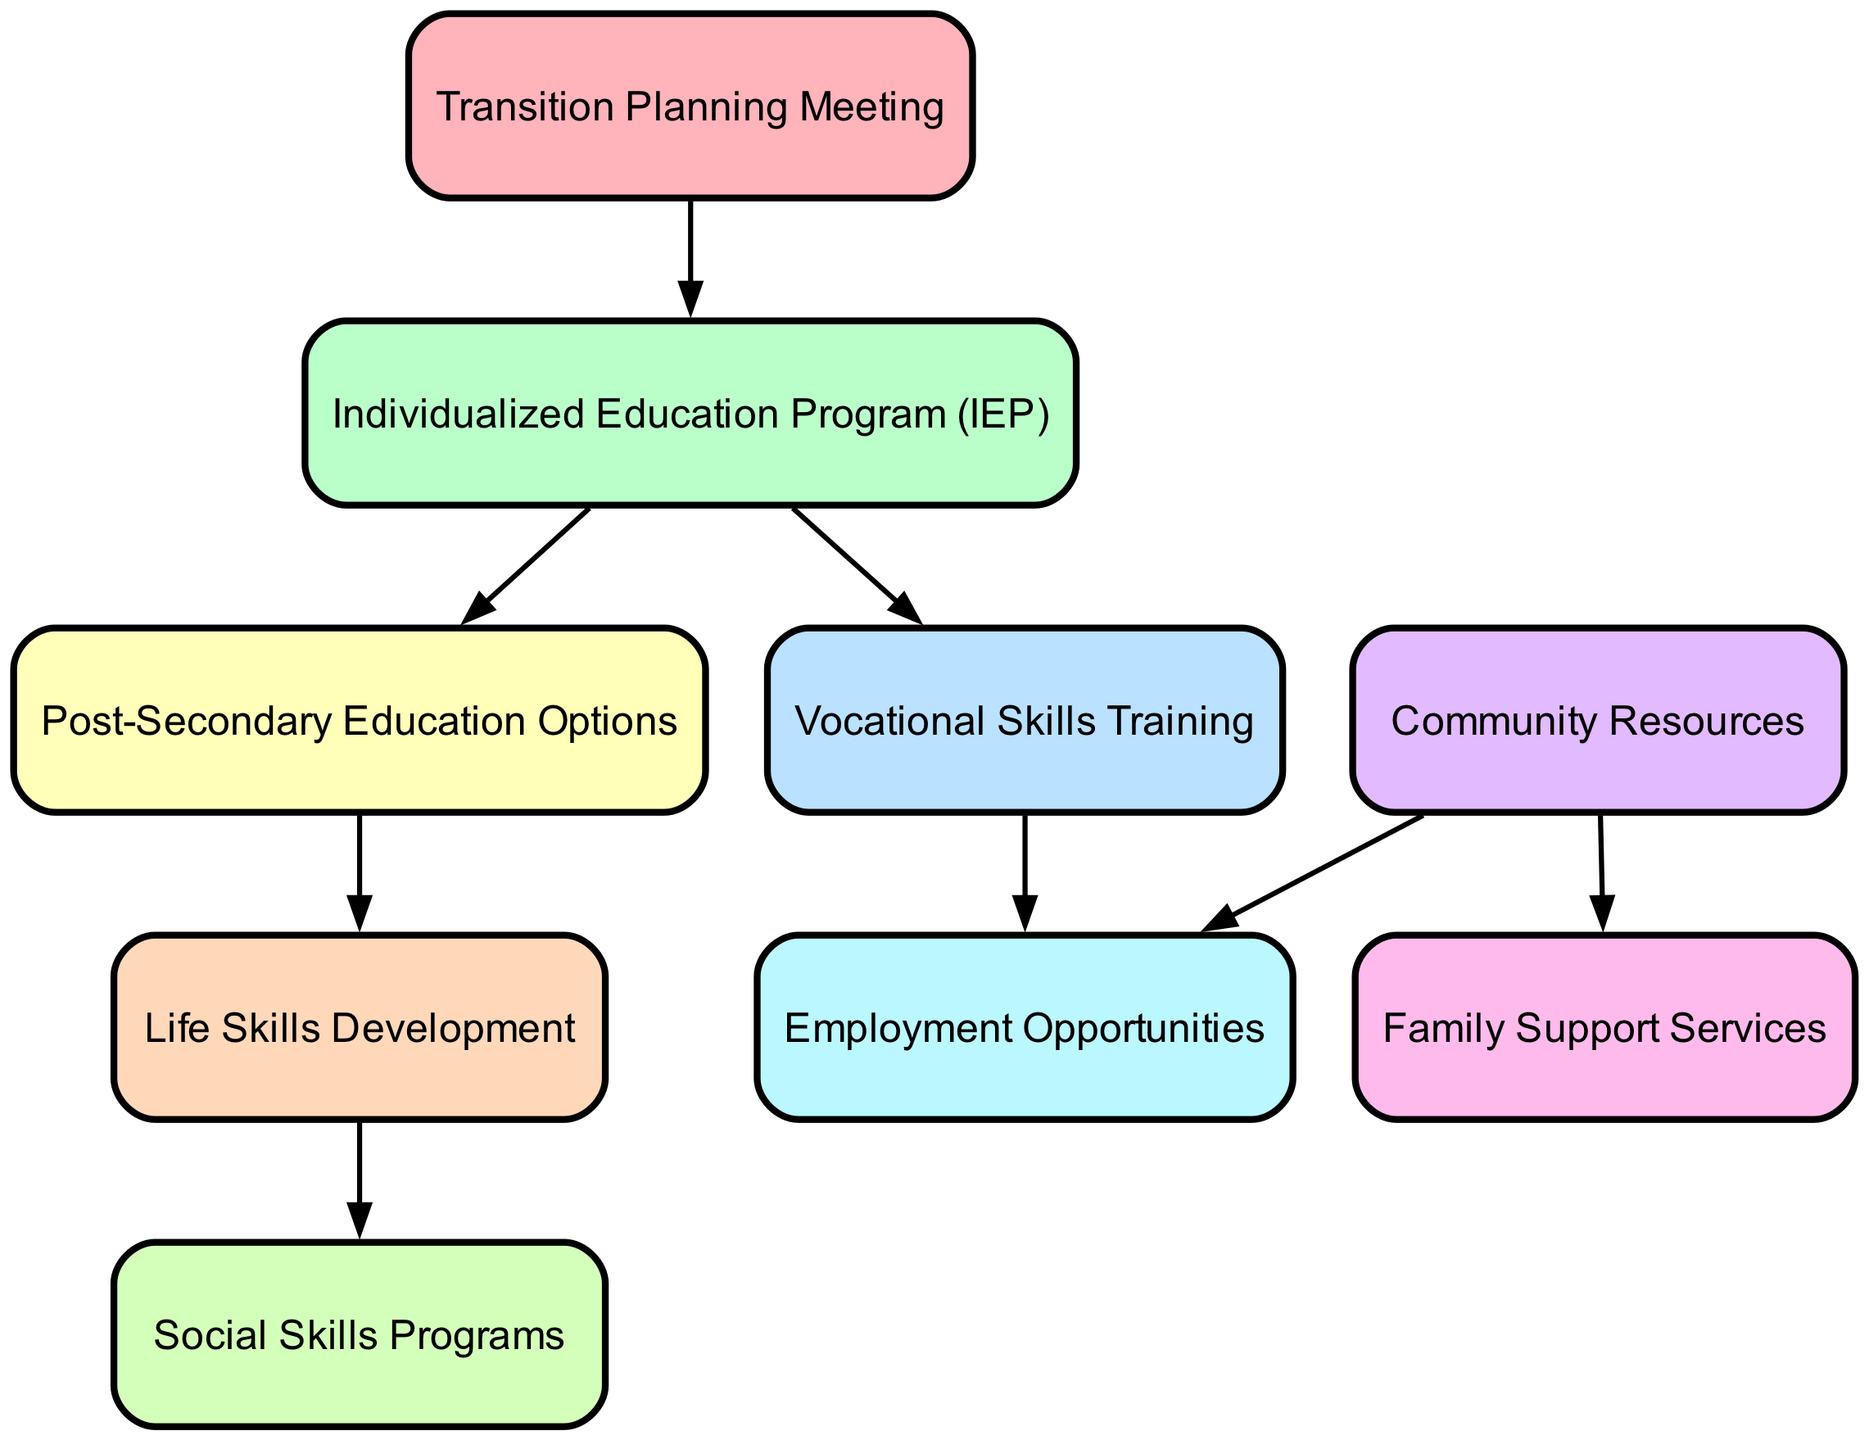What is the total number of nodes in the diagram? The diagram includes individual elements that represent different aspects of transition planning, each defined as a node. Counting them reveals there are nine distinct nodes present in the diagram.
Answer: 9 How many edges connect the "Transition Planning Meeting" to other nodes? The "Transition Planning Meeting" serves as a starting point and connects to multiple nodes, specifically to the "Individualized Education Program (IEP)." By analyzing the edges coming from this node, we find that there is one edge connecting it to the next node.
Answer: 1 What does the "Individualized Education Program (IEP)" lead to? The "Individualized Education Program (IEP)" serves as a pivotal point of the transition process, leading to two subsequent nodes that represent vocational and education options. By checking the edges, it connects directly to the "Vocational Skills Training" and "Post-Secondary Education Options."
Answer: Vocational Skills Training, Post-Secondary Education Options Which node is connected to both "Community Resources" and "Family Support Services"? Investigating the edges stemming from "Community Resources," we can identify what other nodes it connects to. It connects to "Family Support Services" and "Employment Opportunities," indicating the dual connections of the node.
Answer: Family Support Services, Employment Opportunities Identify the relationship between "Life Skills Development" and "Social Skills Programs." The edge leading from "Life Skills Development" to "Social Skills Programs" shows a progression from the development of general life skills to the enhancement of specific social skills, representing a logical development path.
Answer: Life Skills Development leads to Social Skills Programs What node does "Vocational Skills Training" ultimately connect to? Following the directed flows from "Vocational Skills Training," we deduce that it culminates in "Employment Opportunities," representing the end goal of vocational training. The edge indicates a clear link between these two nodes.
Answer: Employment Opportunities 